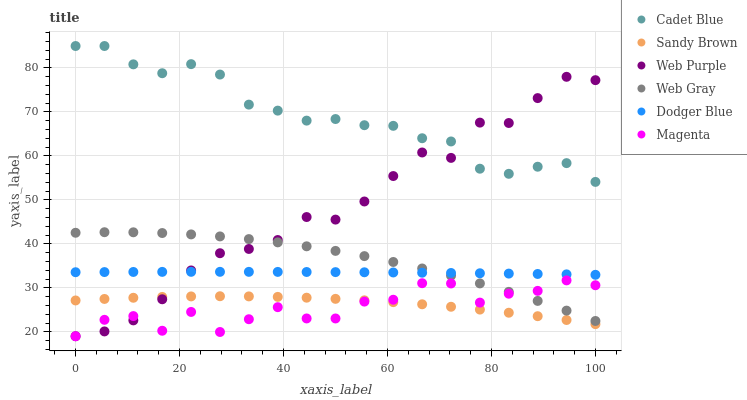Does Magenta have the minimum area under the curve?
Answer yes or no. Yes. Does Cadet Blue have the maximum area under the curve?
Answer yes or no. Yes. Does Web Purple have the minimum area under the curve?
Answer yes or no. No. Does Web Purple have the maximum area under the curve?
Answer yes or no. No. Is Dodger Blue the smoothest?
Answer yes or no. Yes. Is Magenta the roughest?
Answer yes or no. Yes. Is Web Purple the smoothest?
Answer yes or no. No. Is Web Purple the roughest?
Answer yes or no. No. Does Web Purple have the lowest value?
Answer yes or no. Yes. Does Cadet Blue have the lowest value?
Answer yes or no. No. Does Cadet Blue have the highest value?
Answer yes or no. Yes. Does Web Purple have the highest value?
Answer yes or no. No. Is Sandy Brown less than Cadet Blue?
Answer yes or no. Yes. Is Web Gray greater than Sandy Brown?
Answer yes or no. Yes. Does Dodger Blue intersect Web Purple?
Answer yes or no. Yes. Is Dodger Blue less than Web Purple?
Answer yes or no. No. Is Dodger Blue greater than Web Purple?
Answer yes or no. No. Does Sandy Brown intersect Cadet Blue?
Answer yes or no. No. 